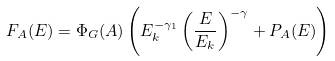<formula> <loc_0><loc_0><loc_500><loc_500>F _ { A } ( E ) = \Phi _ { G } ( A ) \left ( E _ { k } ^ { - \gamma _ { 1 } } \left ( \frac { E } { E _ { k } } \right ) ^ { - \gamma } + P _ { A } ( E ) \right )</formula> 